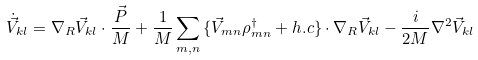Convert formula to latex. <formula><loc_0><loc_0><loc_500><loc_500>\dot { \vec { V } } _ { k l } = \nabla _ { R } \vec { V } _ { k l } \cdot \frac { \vec { P } } { M } + \frac { 1 } { M } \sum _ { m , n } { \{ \vec { V } _ { m n } \rho ^ { \dagger } _ { m n } + h . c \} } \cdot \nabla _ { R } \vec { V } _ { k l } - \frac { i } { 2 M } \nabla ^ { 2 } \vec { V } _ { k l }</formula> 